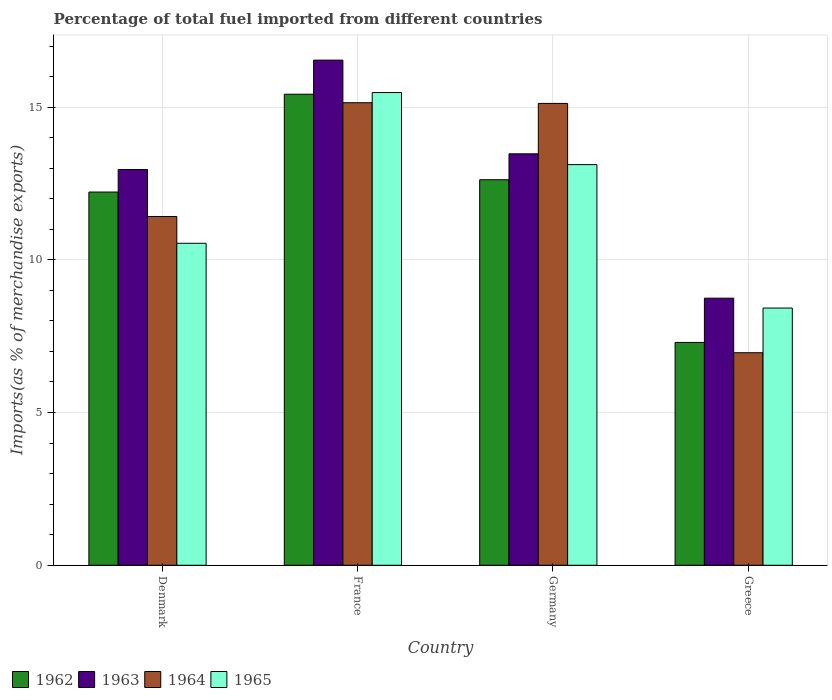How many different coloured bars are there?
Your answer should be very brief. 4. Are the number of bars per tick equal to the number of legend labels?
Offer a terse response. Yes. Are the number of bars on each tick of the X-axis equal?
Ensure brevity in your answer.  Yes. How many bars are there on the 2nd tick from the right?
Make the answer very short. 4. What is the label of the 2nd group of bars from the left?
Keep it short and to the point. France. What is the percentage of imports to different countries in 1962 in France?
Provide a short and direct response. 15.42. Across all countries, what is the maximum percentage of imports to different countries in 1963?
Keep it short and to the point. 16.54. Across all countries, what is the minimum percentage of imports to different countries in 1965?
Offer a terse response. 8.42. What is the total percentage of imports to different countries in 1962 in the graph?
Give a very brief answer. 47.56. What is the difference between the percentage of imports to different countries in 1963 in France and that in Greece?
Your response must be concise. 7.79. What is the difference between the percentage of imports to different countries in 1964 in Germany and the percentage of imports to different countries in 1963 in Greece?
Keep it short and to the point. 6.38. What is the average percentage of imports to different countries in 1962 per country?
Your response must be concise. 11.89. What is the difference between the percentage of imports to different countries of/in 1962 and percentage of imports to different countries of/in 1965 in Greece?
Provide a short and direct response. -1.13. In how many countries, is the percentage of imports to different countries in 1964 greater than 15 %?
Provide a short and direct response. 2. What is the ratio of the percentage of imports to different countries in 1964 in Denmark to that in Greece?
Your response must be concise. 1.64. Is the percentage of imports to different countries in 1964 in Denmark less than that in Germany?
Ensure brevity in your answer.  Yes. What is the difference between the highest and the second highest percentage of imports to different countries in 1965?
Your answer should be compact. -2.58. What is the difference between the highest and the lowest percentage of imports to different countries in 1964?
Your response must be concise. 8.19. In how many countries, is the percentage of imports to different countries in 1964 greater than the average percentage of imports to different countries in 1964 taken over all countries?
Provide a succinct answer. 2. Is the sum of the percentage of imports to different countries in 1965 in Denmark and Greece greater than the maximum percentage of imports to different countries in 1962 across all countries?
Your answer should be compact. Yes. Is it the case that in every country, the sum of the percentage of imports to different countries in 1963 and percentage of imports to different countries in 1965 is greater than the sum of percentage of imports to different countries in 1964 and percentage of imports to different countries in 1962?
Give a very brief answer. No. What does the 2nd bar from the left in Germany represents?
Ensure brevity in your answer.  1963. What does the 1st bar from the right in Germany represents?
Offer a very short reply. 1965. Is it the case that in every country, the sum of the percentage of imports to different countries in 1963 and percentage of imports to different countries in 1962 is greater than the percentage of imports to different countries in 1965?
Make the answer very short. Yes. How many countries are there in the graph?
Your response must be concise. 4. What is the difference between two consecutive major ticks on the Y-axis?
Offer a terse response. 5. Are the values on the major ticks of Y-axis written in scientific E-notation?
Ensure brevity in your answer.  No. How many legend labels are there?
Offer a very short reply. 4. How are the legend labels stacked?
Provide a succinct answer. Horizontal. What is the title of the graph?
Offer a very short reply. Percentage of total fuel imported from different countries. What is the label or title of the X-axis?
Keep it short and to the point. Country. What is the label or title of the Y-axis?
Provide a succinct answer. Imports(as % of merchandise exports). What is the Imports(as % of merchandise exports) of 1962 in Denmark?
Offer a very short reply. 12.22. What is the Imports(as % of merchandise exports) in 1963 in Denmark?
Your answer should be very brief. 12.96. What is the Imports(as % of merchandise exports) of 1964 in Denmark?
Keep it short and to the point. 11.42. What is the Imports(as % of merchandise exports) in 1965 in Denmark?
Your answer should be very brief. 10.54. What is the Imports(as % of merchandise exports) in 1962 in France?
Keep it short and to the point. 15.42. What is the Imports(as % of merchandise exports) of 1963 in France?
Your response must be concise. 16.54. What is the Imports(as % of merchandise exports) in 1964 in France?
Provide a short and direct response. 15.14. What is the Imports(as % of merchandise exports) of 1965 in France?
Offer a terse response. 15.48. What is the Imports(as % of merchandise exports) in 1962 in Germany?
Your answer should be very brief. 12.62. What is the Imports(as % of merchandise exports) in 1963 in Germany?
Offer a very short reply. 13.47. What is the Imports(as % of merchandise exports) in 1964 in Germany?
Keep it short and to the point. 15.12. What is the Imports(as % of merchandise exports) in 1965 in Germany?
Offer a terse response. 13.12. What is the Imports(as % of merchandise exports) of 1962 in Greece?
Give a very brief answer. 7.3. What is the Imports(as % of merchandise exports) of 1963 in Greece?
Your answer should be compact. 8.74. What is the Imports(as % of merchandise exports) of 1964 in Greece?
Provide a short and direct response. 6.96. What is the Imports(as % of merchandise exports) of 1965 in Greece?
Ensure brevity in your answer.  8.42. Across all countries, what is the maximum Imports(as % of merchandise exports) of 1962?
Give a very brief answer. 15.42. Across all countries, what is the maximum Imports(as % of merchandise exports) of 1963?
Provide a succinct answer. 16.54. Across all countries, what is the maximum Imports(as % of merchandise exports) in 1964?
Your answer should be compact. 15.14. Across all countries, what is the maximum Imports(as % of merchandise exports) of 1965?
Make the answer very short. 15.48. Across all countries, what is the minimum Imports(as % of merchandise exports) in 1962?
Keep it short and to the point. 7.3. Across all countries, what is the minimum Imports(as % of merchandise exports) in 1963?
Give a very brief answer. 8.74. Across all countries, what is the minimum Imports(as % of merchandise exports) of 1964?
Make the answer very short. 6.96. Across all countries, what is the minimum Imports(as % of merchandise exports) of 1965?
Offer a terse response. 8.42. What is the total Imports(as % of merchandise exports) of 1962 in the graph?
Give a very brief answer. 47.56. What is the total Imports(as % of merchandise exports) in 1963 in the graph?
Offer a very short reply. 51.71. What is the total Imports(as % of merchandise exports) of 1964 in the graph?
Your answer should be very brief. 48.64. What is the total Imports(as % of merchandise exports) of 1965 in the graph?
Keep it short and to the point. 47.56. What is the difference between the Imports(as % of merchandise exports) in 1962 in Denmark and that in France?
Give a very brief answer. -3.2. What is the difference between the Imports(as % of merchandise exports) of 1963 in Denmark and that in France?
Your answer should be very brief. -3.58. What is the difference between the Imports(as % of merchandise exports) in 1964 in Denmark and that in France?
Ensure brevity in your answer.  -3.72. What is the difference between the Imports(as % of merchandise exports) in 1965 in Denmark and that in France?
Make the answer very short. -4.94. What is the difference between the Imports(as % of merchandise exports) in 1962 in Denmark and that in Germany?
Keep it short and to the point. -0.4. What is the difference between the Imports(as % of merchandise exports) of 1963 in Denmark and that in Germany?
Your answer should be very brief. -0.51. What is the difference between the Imports(as % of merchandise exports) of 1964 in Denmark and that in Germany?
Offer a terse response. -3.7. What is the difference between the Imports(as % of merchandise exports) of 1965 in Denmark and that in Germany?
Your response must be concise. -2.58. What is the difference between the Imports(as % of merchandise exports) of 1962 in Denmark and that in Greece?
Offer a terse response. 4.92. What is the difference between the Imports(as % of merchandise exports) in 1963 in Denmark and that in Greece?
Provide a short and direct response. 4.21. What is the difference between the Imports(as % of merchandise exports) in 1964 in Denmark and that in Greece?
Keep it short and to the point. 4.46. What is the difference between the Imports(as % of merchandise exports) of 1965 in Denmark and that in Greece?
Ensure brevity in your answer.  2.12. What is the difference between the Imports(as % of merchandise exports) of 1962 in France and that in Germany?
Offer a terse response. 2.8. What is the difference between the Imports(as % of merchandise exports) of 1963 in France and that in Germany?
Offer a very short reply. 3.07. What is the difference between the Imports(as % of merchandise exports) in 1964 in France and that in Germany?
Your answer should be compact. 0.02. What is the difference between the Imports(as % of merchandise exports) of 1965 in France and that in Germany?
Your answer should be compact. 2.36. What is the difference between the Imports(as % of merchandise exports) in 1962 in France and that in Greece?
Your answer should be very brief. 8.13. What is the difference between the Imports(as % of merchandise exports) of 1963 in France and that in Greece?
Ensure brevity in your answer.  7.79. What is the difference between the Imports(as % of merchandise exports) of 1964 in France and that in Greece?
Provide a succinct answer. 8.19. What is the difference between the Imports(as % of merchandise exports) of 1965 in France and that in Greece?
Make the answer very short. 7.06. What is the difference between the Imports(as % of merchandise exports) in 1962 in Germany and that in Greece?
Provide a short and direct response. 5.33. What is the difference between the Imports(as % of merchandise exports) in 1963 in Germany and that in Greece?
Give a very brief answer. 4.73. What is the difference between the Imports(as % of merchandise exports) of 1964 in Germany and that in Greece?
Keep it short and to the point. 8.16. What is the difference between the Imports(as % of merchandise exports) in 1965 in Germany and that in Greece?
Ensure brevity in your answer.  4.7. What is the difference between the Imports(as % of merchandise exports) of 1962 in Denmark and the Imports(as % of merchandise exports) of 1963 in France?
Provide a succinct answer. -4.32. What is the difference between the Imports(as % of merchandise exports) in 1962 in Denmark and the Imports(as % of merchandise exports) in 1964 in France?
Ensure brevity in your answer.  -2.92. What is the difference between the Imports(as % of merchandise exports) of 1962 in Denmark and the Imports(as % of merchandise exports) of 1965 in France?
Your response must be concise. -3.26. What is the difference between the Imports(as % of merchandise exports) of 1963 in Denmark and the Imports(as % of merchandise exports) of 1964 in France?
Your answer should be compact. -2.19. What is the difference between the Imports(as % of merchandise exports) in 1963 in Denmark and the Imports(as % of merchandise exports) in 1965 in France?
Offer a very short reply. -2.52. What is the difference between the Imports(as % of merchandise exports) in 1964 in Denmark and the Imports(as % of merchandise exports) in 1965 in France?
Your answer should be very brief. -4.06. What is the difference between the Imports(as % of merchandise exports) of 1962 in Denmark and the Imports(as % of merchandise exports) of 1963 in Germany?
Give a very brief answer. -1.25. What is the difference between the Imports(as % of merchandise exports) of 1962 in Denmark and the Imports(as % of merchandise exports) of 1964 in Germany?
Provide a succinct answer. -2.9. What is the difference between the Imports(as % of merchandise exports) in 1962 in Denmark and the Imports(as % of merchandise exports) in 1965 in Germany?
Provide a short and direct response. -0.9. What is the difference between the Imports(as % of merchandise exports) in 1963 in Denmark and the Imports(as % of merchandise exports) in 1964 in Germany?
Provide a short and direct response. -2.16. What is the difference between the Imports(as % of merchandise exports) in 1963 in Denmark and the Imports(as % of merchandise exports) in 1965 in Germany?
Your answer should be very brief. -0.16. What is the difference between the Imports(as % of merchandise exports) in 1964 in Denmark and the Imports(as % of merchandise exports) in 1965 in Germany?
Offer a very short reply. -1.7. What is the difference between the Imports(as % of merchandise exports) in 1962 in Denmark and the Imports(as % of merchandise exports) in 1963 in Greece?
Provide a short and direct response. 3.48. What is the difference between the Imports(as % of merchandise exports) in 1962 in Denmark and the Imports(as % of merchandise exports) in 1964 in Greece?
Offer a terse response. 5.26. What is the difference between the Imports(as % of merchandise exports) in 1962 in Denmark and the Imports(as % of merchandise exports) in 1965 in Greece?
Make the answer very short. 3.8. What is the difference between the Imports(as % of merchandise exports) in 1963 in Denmark and the Imports(as % of merchandise exports) in 1964 in Greece?
Your answer should be very brief. 6. What is the difference between the Imports(as % of merchandise exports) in 1963 in Denmark and the Imports(as % of merchandise exports) in 1965 in Greece?
Provide a succinct answer. 4.54. What is the difference between the Imports(as % of merchandise exports) in 1964 in Denmark and the Imports(as % of merchandise exports) in 1965 in Greece?
Your response must be concise. 3. What is the difference between the Imports(as % of merchandise exports) in 1962 in France and the Imports(as % of merchandise exports) in 1963 in Germany?
Make the answer very short. 1.95. What is the difference between the Imports(as % of merchandise exports) in 1962 in France and the Imports(as % of merchandise exports) in 1964 in Germany?
Offer a terse response. 0.3. What is the difference between the Imports(as % of merchandise exports) of 1962 in France and the Imports(as % of merchandise exports) of 1965 in Germany?
Ensure brevity in your answer.  2.31. What is the difference between the Imports(as % of merchandise exports) in 1963 in France and the Imports(as % of merchandise exports) in 1964 in Germany?
Your answer should be very brief. 1.42. What is the difference between the Imports(as % of merchandise exports) of 1963 in France and the Imports(as % of merchandise exports) of 1965 in Germany?
Keep it short and to the point. 3.42. What is the difference between the Imports(as % of merchandise exports) in 1964 in France and the Imports(as % of merchandise exports) in 1965 in Germany?
Make the answer very short. 2.03. What is the difference between the Imports(as % of merchandise exports) in 1962 in France and the Imports(as % of merchandise exports) in 1963 in Greece?
Provide a succinct answer. 6.68. What is the difference between the Imports(as % of merchandise exports) of 1962 in France and the Imports(as % of merchandise exports) of 1964 in Greece?
Your answer should be very brief. 8.46. What is the difference between the Imports(as % of merchandise exports) in 1962 in France and the Imports(as % of merchandise exports) in 1965 in Greece?
Offer a very short reply. 7. What is the difference between the Imports(as % of merchandise exports) of 1963 in France and the Imports(as % of merchandise exports) of 1964 in Greece?
Offer a terse response. 9.58. What is the difference between the Imports(as % of merchandise exports) in 1963 in France and the Imports(as % of merchandise exports) in 1965 in Greece?
Provide a succinct answer. 8.12. What is the difference between the Imports(as % of merchandise exports) in 1964 in France and the Imports(as % of merchandise exports) in 1965 in Greece?
Provide a succinct answer. 6.72. What is the difference between the Imports(as % of merchandise exports) in 1962 in Germany and the Imports(as % of merchandise exports) in 1963 in Greece?
Give a very brief answer. 3.88. What is the difference between the Imports(as % of merchandise exports) in 1962 in Germany and the Imports(as % of merchandise exports) in 1964 in Greece?
Provide a succinct answer. 5.66. What is the difference between the Imports(as % of merchandise exports) in 1962 in Germany and the Imports(as % of merchandise exports) in 1965 in Greece?
Give a very brief answer. 4.2. What is the difference between the Imports(as % of merchandise exports) of 1963 in Germany and the Imports(as % of merchandise exports) of 1964 in Greece?
Provide a short and direct response. 6.51. What is the difference between the Imports(as % of merchandise exports) in 1963 in Germany and the Imports(as % of merchandise exports) in 1965 in Greece?
Offer a terse response. 5.05. What is the difference between the Imports(as % of merchandise exports) in 1964 in Germany and the Imports(as % of merchandise exports) in 1965 in Greece?
Your answer should be compact. 6.7. What is the average Imports(as % of merchandise exports) in 1962 per country?
Ensure brevity in your answer.  11.89. What is the average Imports(as % of merchandise exports) in 1963 per country?
Give a very brief answer. 12.93. What is the average Imports(as % of merchandise exports) in 1964 per country?
Offer a very short reply. 12.16. What is the average Imports(as % of merchandise exports) in 1965 per country?
Your response must be concise. 11.89. What is the difference between the Imports(as % of merchandise exports) in 1962 and Imports(as % of merchandise exports) in 1963 in Denmark?
Your answer should be very brief. -0.74. What is the difference between the Imports(as % of merchandise exports) of 1962 and Imports(as % of merchandise exports) of 1964 in Denmark?
Your answer should be very brief. 0.8. What is the difference between the Imports(as % of merchandise exports) in 1962 and Imports(as % of merchandise exports) in 1965 in Denmark?
Offer a terse response. 1.68. What is the difference between the Imports(as % of merchandise exports) of 1963 and Imports(as % of merchandise exports) of 1964 in Denmark?
Keep it short and to the point. 1.54. What is the difference between the Imports(as % of merchandise exports) of 1963 and Imports(as % of merchandise exports) of 1965 in Denmark?
Keep it short and to the point. 2.42. What is the difference between the Imports(as % of merchandise exports) of 1964 and Imports(as % of merchandise exports) of 1965 in Denmark?
Keep it short and to the point. 0.88. What is the difference between the Imports(as % of merchandise exports) in 1962 and Imports(as % of merchandise exports) in 1963 in France?
Provide a short and direct response. -1.12. What is the difference between the Imports(as % of merchandise exports) of 1962 and Imports(as % of merchandise exports) of 1964 in France?
Give a very brief answer. 0.28. What is the difference between the Imports(as % of merchandise exports) of 1962 and Imports(as % of merchandise exports) of 1965 in France?
Make the answer very short. -0.05. What is the difference between the Imports(as % of merchandise exports) of 1963 and Imports(as % of merchandise exports) of 1964 in France?
Your response must be concise. 1.39. What is the difference between the Imports(as % of merchandise exports) in 1963 and Imports(as % of merchandise exports) in 1965 in France?
Give a very brief answer. 1.06. What is the difference between the Imports(as % of merchandise exports) of 1964 and Imports(as % of merchandise exports) of 1965 in France?
Give a very brief answer. -0.33. What is the difference between the Imports(as % of merchandise exports) in 1962 and Imports(as % of merchandise exports) in 1963 in Germany?
Offer a very short reply. -0.85. What is the difference between the Imports(as % of merchandise exports) of 1962 and Imports(as % of merchandise exports) of 1964 in Germany?
Keep it short and to the point. -2.5. What is the difference between the Imports(as % of merchandise exports) of 1962 and Imports(as % of merchandise exports) of 1965 in Germany?
Your answer should be compact. -0.49. What is the difference between the Imports(as % of merchandise exports) of 1963 and Imports(as % of merchandise exports) of 1964 in Germany?
Your answer should be compact. -1.65. What is the difference between the Imports(as % of merchandise exports) in 1963 and Imports(as % of merchandise exports) in 1965 in Germany?
Ensure brevity in your answer.  0.35. What is the difference between the Imports(as % of merchandise exports) of 1964 and Imports(as % of merchandise exports) of 1965 in Germany?
Make the answer very short. 2. What is the difference between the Imports(as % of merchandise exports) of 1962 and Imports(as % of merchandise exports) of 1963 in Greece?
Provide a short and direct response. -1.45. What is the difference between the Imports(as % of merchandise exports) of 1962 and Imports(as % of merchandise exports) of 1964 in Greece?
Provide a short and direct response. 0.34. What is the difference between the Imports(as % of merchandise exports) in 1962 and Imports(as % of merchandise exports) in 1965 in Greece?
Ensure brevity in your answer.  -1.13. What is the difference between the Imports(as % of merchandise exports) in 1963 and Imports(as % of merchandise exports) in 1964 in Greece?
Give a very brief answer. 1.79. What is the difference between the Imports(as % of merchandise exports) of 1963 and Imports(as % of merchandise exports) of 1965 in Greece?
Keep it short and to the point. 0.32. What is the difference between the Imports(as % of merchandise exports) in 1964 and Imports(as % of merchandise exports) in 1965 in Greece?
Your response must be concise. -1.46. What is the ratio of the Imports(as % of merchandise exports) of 1962 in Denmark to that in France?
Give a very brief answer. 0.79. What is the ratio of the Imports(as % of merchandise exports) of 1963 in Denmark to that in France?
Your response must be concise. 0.78. What is the ratio of the Imports(as % of merchandise exports) in 1964 in Denmark to that in France?
Provide a short and direct response. 0.75. What is the ratio of the Imports(as % of merchandise exports) of 1965 in Denmark to that in France?
Your answer should be compact. 0.68. What is the ratio of the Imports(as % of merchandise exports) in 1963 in Denmark to that in Germany?
Offer a very short reply. 0.96. What is the ratio of the Imports(as % of merchandise exports) of 1964 in Denmark to that in Germany?
Your response must be concise. 0.76. What is the ratio of the Imports(as % of merchandise exports) in 1965 in Denmark to that in Germany?
Provide a short and direct response. 0.8. What is the ratio of the Imports(as % of merchandise exports) in 1962 in Denmark to that in Greece?
Your answer should be compact. 1.67. What is the ratio of the Imports(as % of merchandise exports) of 1963 in Denmark to that in Greece?
Offer a terse response. 1.48. What is the ratio of the Imports(as % of merchandise exports) of 1964 in Denmark to that in Greece?
Ensure brevity in your answer.  1.64. What is the ratio of the Imports(as % of merchandise exports) in 1965 in Denmark to that in Greece?
Provide a short and direct response. 1.25. What is the ratio of the Imports(as % of merchandise exports) in 1962 in France to that in Germany?
Keep it short and to the point. 1.22. What is the ratio of the Imports(as % of merchandise exports) in 1963 in France to that in Germany?
Your answer should be very brief. 1.23. What is the ratio of the Imports(as % of merchandise exports) in 1965 in France to that in Germany?
Offer a very short reply. 1.18. What is the ratio of the Imports(as % of merchandise exports) in 1962 in France to that in Greece?
Your answer should be compact. 2.11. What is the ratio of the Imports(as % of merchandise exports) in 1963 in France to that in Greece?
Make the answer very short. 1.89. What is the ratio of the Imports(as % of merchandise exports) in 1964 in France to that in Greece?
Your answer should be compact. 2.18. What is the ratio of the Imports(as % of merchandise exports) of 1965 in France to that in Greece?
Provide a short and direct response. 1.84. What is the ratio of the Imports(as % of merchandise exports) of 1962 in Germany to that in Greece?
Your answer should be very brief. 1.73. What is the ratio of the Imports(as % of merchandise exports) of 1963 in Germany to that in Greece?
Keep it short and to the point. 1.54. What is the ratio of the Imports(as % of merchandise exports) of 1964 in Germany to that in Greece?
Offer a very short reply. 2.17. What is the ratio of the Imports(as % of merchandise exports) of 1965 in Germany to that in Greece?
Provide a succinct answer. 1.56. What is the difference between the highest and the second highest Imports(as % of merchandise exports) of 1962?
Give a very brief answer. 2.8. What is the difference between the highest and the second highest Imports(as % of merchandise exports) in 1963?
Provide a succinct answer. 3.07. What is the difference between the highest and the second highest Imports(as % of merchandise exports) of 1964?
Give a very brief answer. 0.02. What is the difference between the highest and the second highest Imports(as % of merchandise exports) of 1965?
Ensure brevity in your answer.  2.36. What is the difference between the highest and the lowest Imports(as % of merchandise exports) in 1962?
Your answer should be compact. 8.13. What is the difference between the highest and the lowest Imports(as % of merchandise exports) of 1963?
Ensure brevity in your answer.  7.79. What is the difference between the highest and the lowest Imports(as % of merchandise exports) in 1964?
Provide a short and direct response. 8.19. What is the difference between the highest and the lowest Imports(as % of merchandise exports) of 1965?
Your answer should be compact. 7.06. 